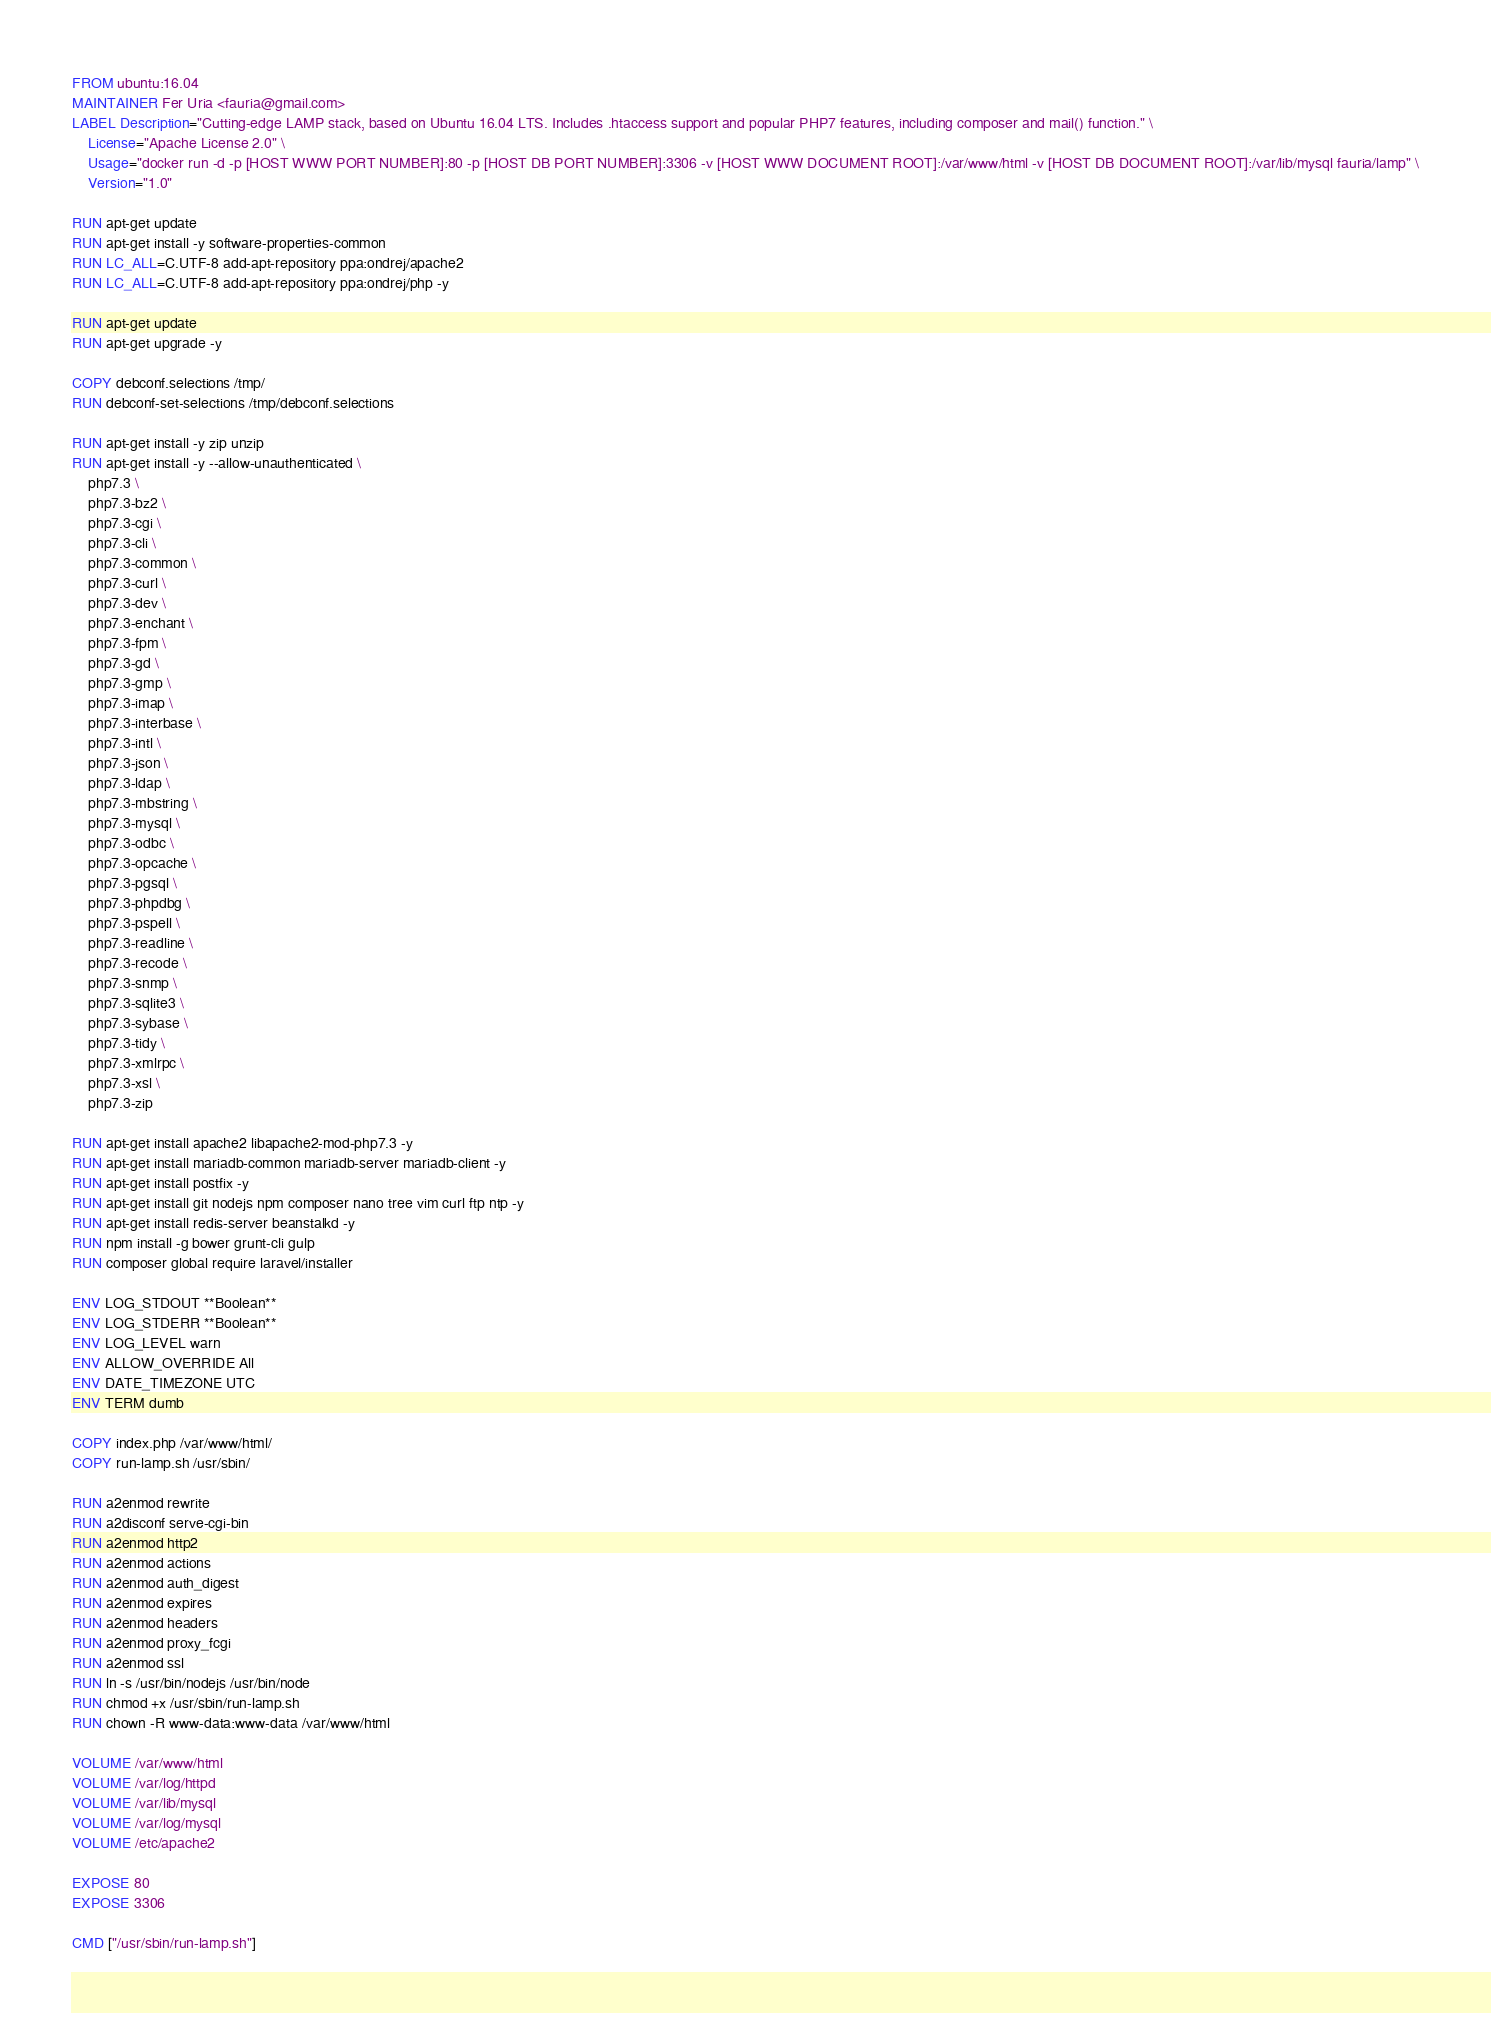Convert code to text. <code><loc_0><loc_0><loc_500><loc_500><_Dockerfile_>FROM ubuntu:16.04
MAINTAINER Fer Uria <fauria@gmail.com>
LABEL Description="Cutting-edge LAMP stack, based on Ubuntu 16.04 LTS. Includes .htaccess support and popular PHP7 features, including composer and mail() function." \
	License="Apache License 2.0" \
	Usage="docker run -d -p [HOST WWW PORT NUMBER]:80 -p [HOST DB PORT NUMBER]:3306 -v [HOST WWW DOCUMENT ROOT]:/var/www/html -v [HOST DB DOCUMENT ROOT]:/var/lib/mysql fauria/lamp" \
	Version="1.0"

RUN apt-get update
RUN apt-get install -y software-properties-common
RUN LC_ALL=C.UTF-8 add-apt-repository ppa:ondrej/apache2
RUN LC_ALL=C.UTF-8 add-apt-repository ppa:ondrej/php -y

RUN apt-get update
RUN apt-get upgrade -y

COPY debconf.selections /tmp/
RUN debconf-set-selections /tmp/debconf.selections

RUN apt-get install -y zip unzip
RUN apt-get install -y --allow-unauthenticated \
	php7.3 \
	php7.3-bz2 \
	php7.3-cgi \
	php7.3-cli \
	php7.3-common \
	php7.3-curl \
	php7.3-dev \
	php7.3-enchant \
	php7.3-fpm \
	php7.3-gd \
	php7.3-gmp \
	php7.3-imap \
	php7.3-interbase \
	php7.3-intl \
	php7.3-json \
	php7.3-ldap \
	php7.3-mbstring \
	php7.3-mysql \
	php7.3-odbc \
	php7.3-opcache \
	php7.3-pgsql \
	php7.3-phpdbg \
	php7.3-pspell \
	php7.3-readline \
	php7.3-recode \
	php7.3-snmp \
	php7.3-sqlite3 \
	php7.3-sybase \
	php7.3-tidy \
	php7.3-xmlrpc \
	php7.3-xsl \
	php7.3-zip
	
RUN apt-get install apache2 libapache2-mod-php7.3 -y
RUN apt-get install mariadb-common mariadb-server mariadb-client -y
RUN apt-get install postfix -y
RUN apt-get install git nodejs npm composer nano tree vim curl ftp ntp -y
RUN apt-get install redis-server beanstalkd -y
RUN npm install -g bower grunt-cli gulp
RUN composer global require laravel/installer

ENV LOG_STDOUT **Boolean**
ENV LOG_STDERR **Boolean**
ENV LOG_LEVEL warn
ENV ALLOW_OVERRIDE All
ENV DATE_TIMEZONE UTC
ENV TERM dumb

COPY index.php /var/www/html/
COPY run-lamp.sh /usr/sbin/

RUN a2enmod rewrite
RUN a2disconf serve-cgi-bin
RUN a2enmod http2
RUN a2enmod actions
RUN a2enmod auth_digest
RUN a2enmod expires
RUN a2enmod headers
RUN a2enmod proxy_fcgi
RUN a2enmod ssl
RUN ln -s /usr/bin/nodejs /usr/bin/node
RUN chmod +x /usr/sbin/run-lamp.sh
RUN chown -R www-data:www-data /var/www/html

VOLUME /var/www/html
VOLUME /var/log/httpd
VOLUME /var/lib/mysql
VOLUME /var/log/mysql
VOLUME /etc/apache2

EXPOSE 80
EXPOSE 3306

CMD ["/usr/sbin/run-lamp.sh"]
</code> 